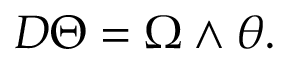Convert formula to latex. <formula><loc_0><loc_0><loc_500><loc_500>D \Theta = \Omega \wedge \theta .</formula> 